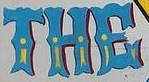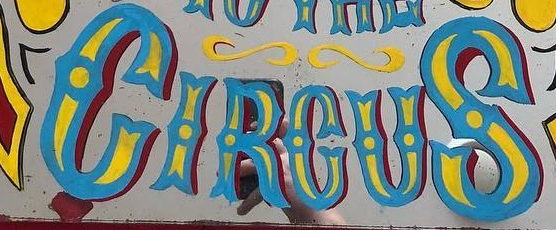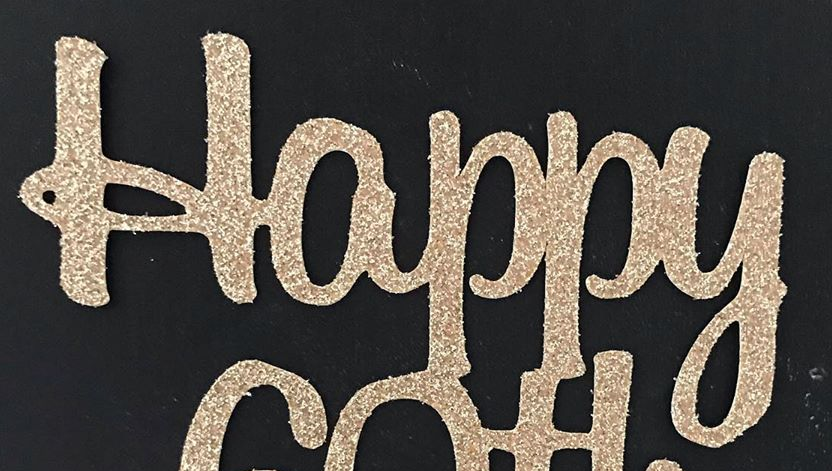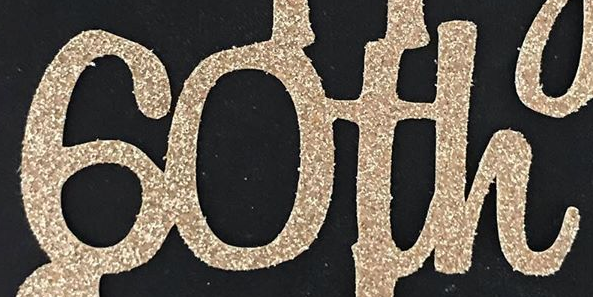Transcribe the words shown in these images in order, separated by a semicolon. THE; CIRCUS; Happy; 60th 